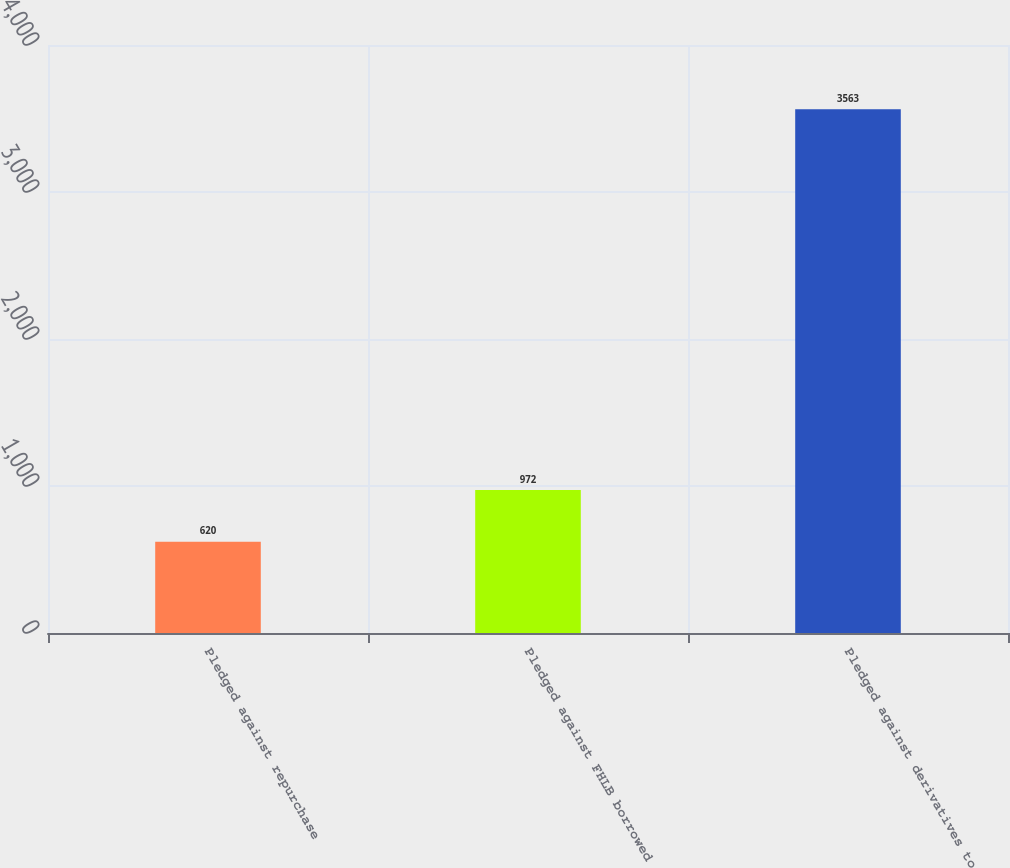Convert chart. <chart><loc_0><loc_0><loc_500><loc_500><bar_chart><fcel>Pledged against repurchase<fcel>Pledged against FHLB borrowed<fcel>Pledged against derivatives to<nl><fcel>620<fcel>972<fcel>3563<nl></chart> 